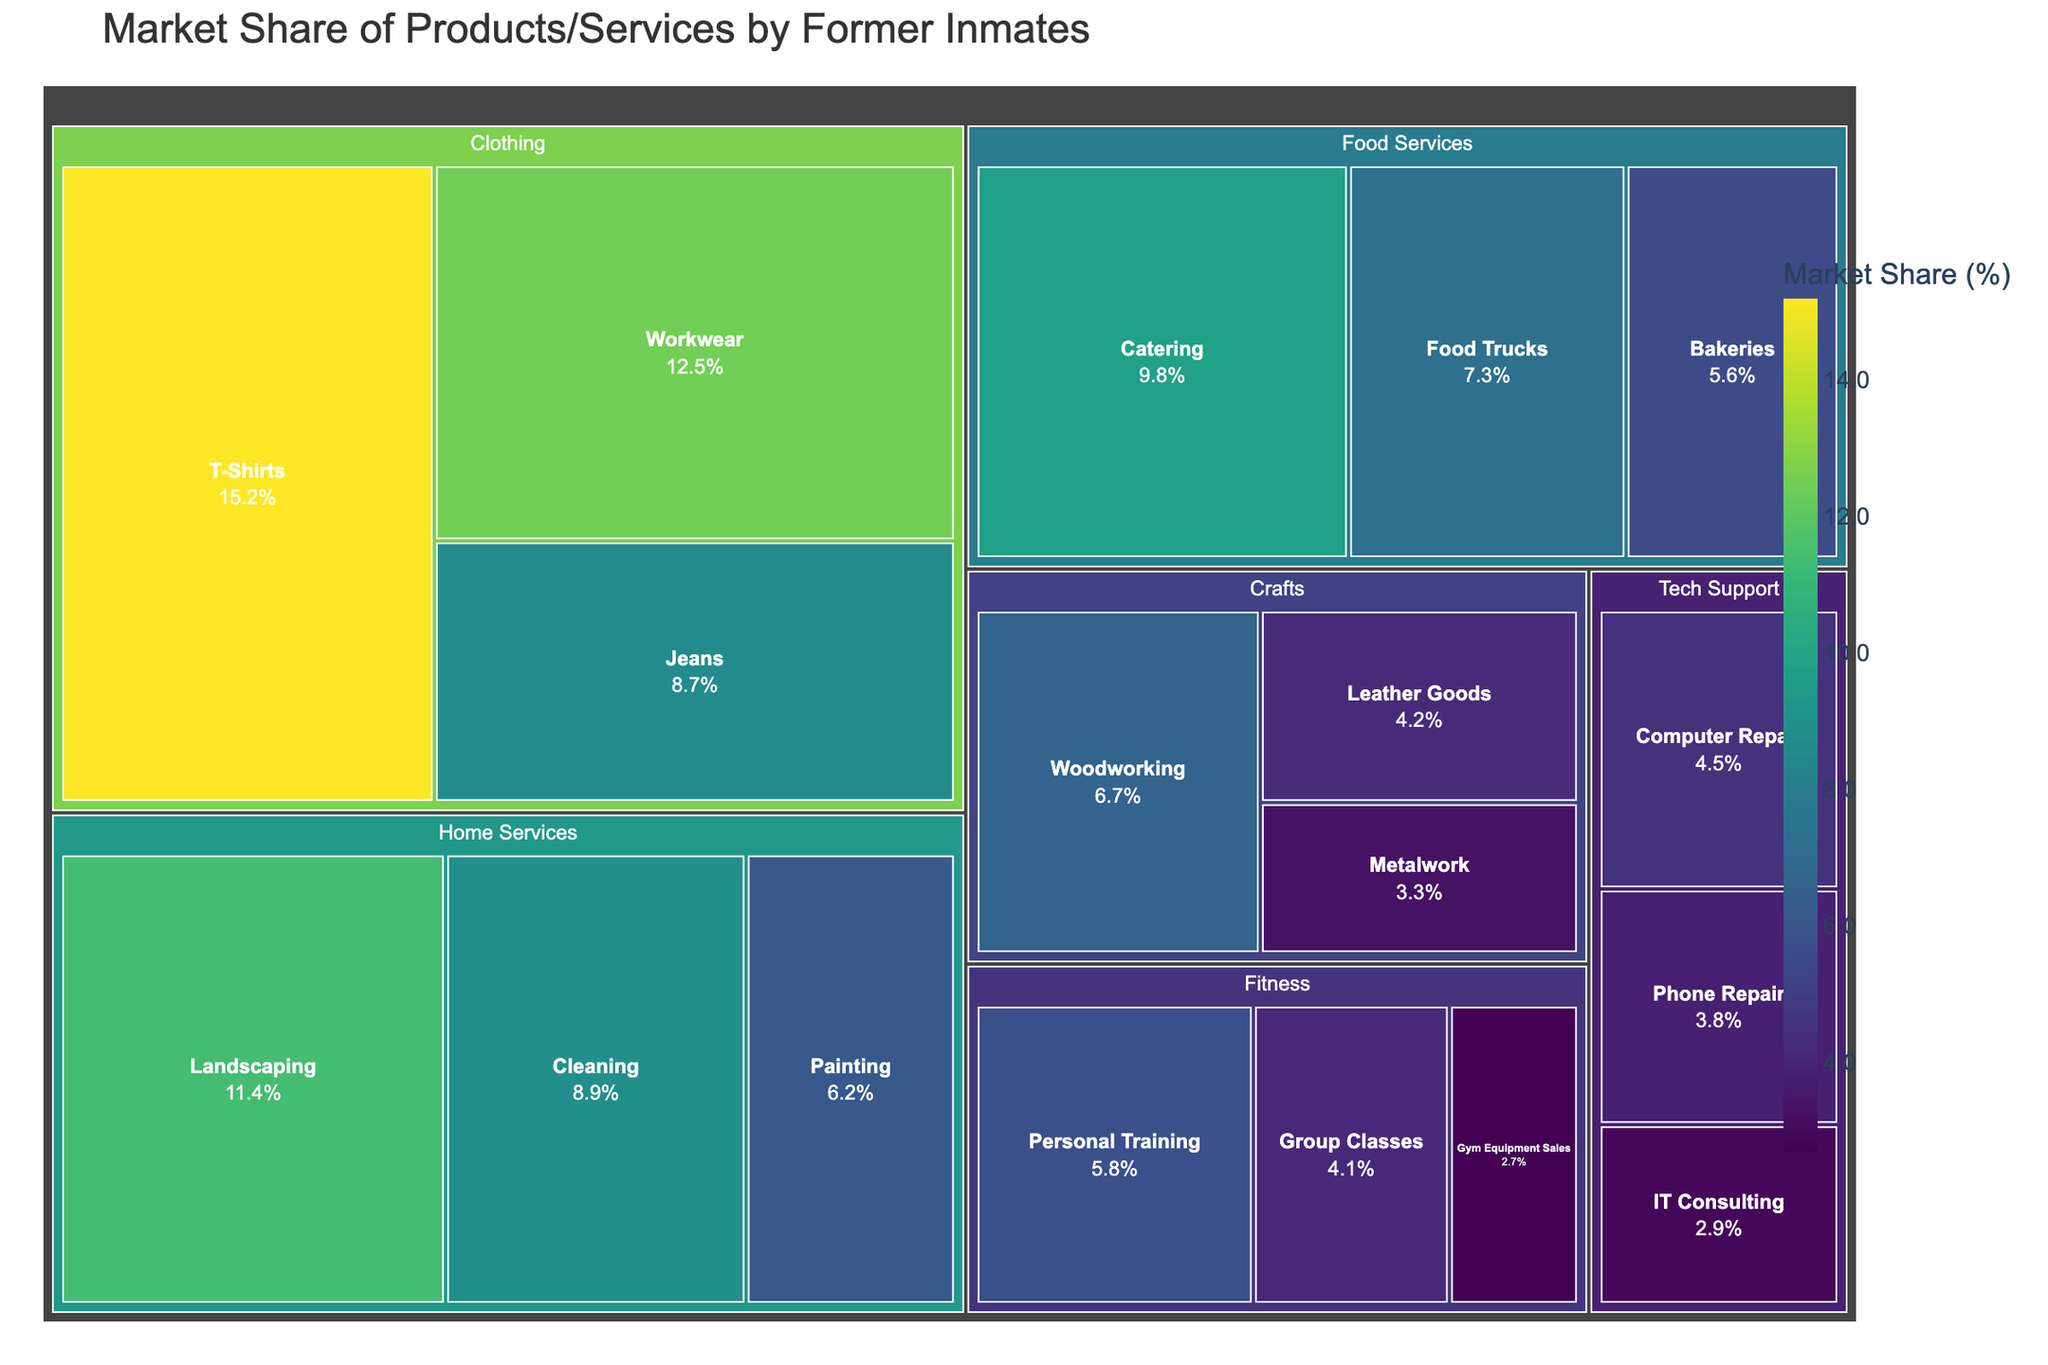What's the category with the highest market share? To find the category with the highest market share, sum up the market shares of all subcategories within each main category and compare them. Clothing has shares: 15.2, 8.7, 12.5, summing to 36.4%. Food Services has 9.8, 7.3, 5.6, summing to 22.7%. Home Services has 11.4, 8.9, 6.2, summing to 26.5%. Tech Support has 4.5, 3.8, 2.9, summing to 11.2%. Crafts has 6.7, 4.2, 3.3, summing to 14.2%. Fitness has 5.8, 4.1, 2.7, summing to 12.6%. Therefore, Clothing has the highest market share.
Answer: Clothing Which subcategory has the least market share in the Food Services category? To identify the subcategory with the least market share, compare the values in the Food Services category. The options are Catering (9.8%), Food Trucks (7.3%), and Bakeries (5.6%). 5.6% is the least.
Answer: Bakeries What's the total market share for the Tech Support category? The Tech Support category includes Computer Repair (4.5%), Phone Repair (3.8%), and IT Consulting (2.9%). Adding these values gives 4.5 + 3.8 + 2.9 = 11.2%.
Answer: 11.2% Is the market share of Landscaping greater than that of Painting? Checking the values for both subcategories: Landscaping has 11.4% and Painting has 6.2%. Since 11.4 > 6.2, Landscaping has a greater market share.
Answer: Yes How many subcategories are displayed in the Fitness category? In the Fitness category, the subcategories listed are Personal Training, Group Classes, and Gym Equipment Sales. Counting these gives a total of 3 subcategories.
Answer: 3 Which has a higher market share: Leather Goods or Metalwork in the Crafts category? Checking market shares within the Crafts category: Leather Goods has 4.2% and Metalwork has 3.3%. Since 4.2 > 3.3, Leather Goods has a higher market share.
Answer: Leather Goods What's the combined market share of T-Shirts and Workwear in Clothing? T-Shirts have 15.2% and Workwear has 12.5%. The combined market share is 15.2 + 12.5 = 27.7%.
Answer: 27.7% Which subcategory in Home Services has the highest market share? Comparing Landscaping (11.4%), Cleaning (8.9%), and Painting (6.2%), Landscaping has the highest market share.
Answer: Landscaping Is the market share of the Clothing category higher than the Home Services category? Summing up the Clothing shares (15.2, 8.7, 12.5) gives 36.4%. Summing up the Home Services shares (11.4, 8.9, 6.2) gives 26.5%. Since 36.4 > 26.5, the Clothing category's market share is higher.
Answer: Yes Which category has the smallest market share percentage in Tech Support? The Tech Support market shares are Computer Repair (4.5%), Phone Repair (3.8%), and IT Consulting (2.9%). IT Consulting has the smallest share at 2.9%.
Answer: IT Consulting 